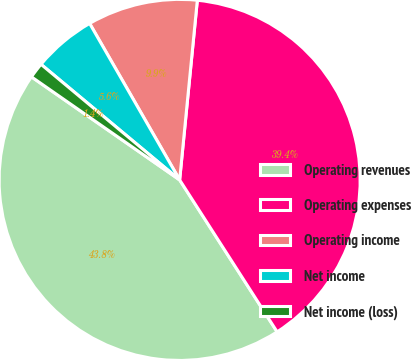<chart> <loc_0><loc_0><loc_500><loc_500><pie_chart><fcel>Operating revenues<fcel>Operating expenses<fcel>Operating income<fcel>Net income<fcel>Net income (loss)<nl><fcel>43.75%<fcel>39.36%<fcel>9.87%<fcel>5.63%<fcel>1.39%<nl></chart> 